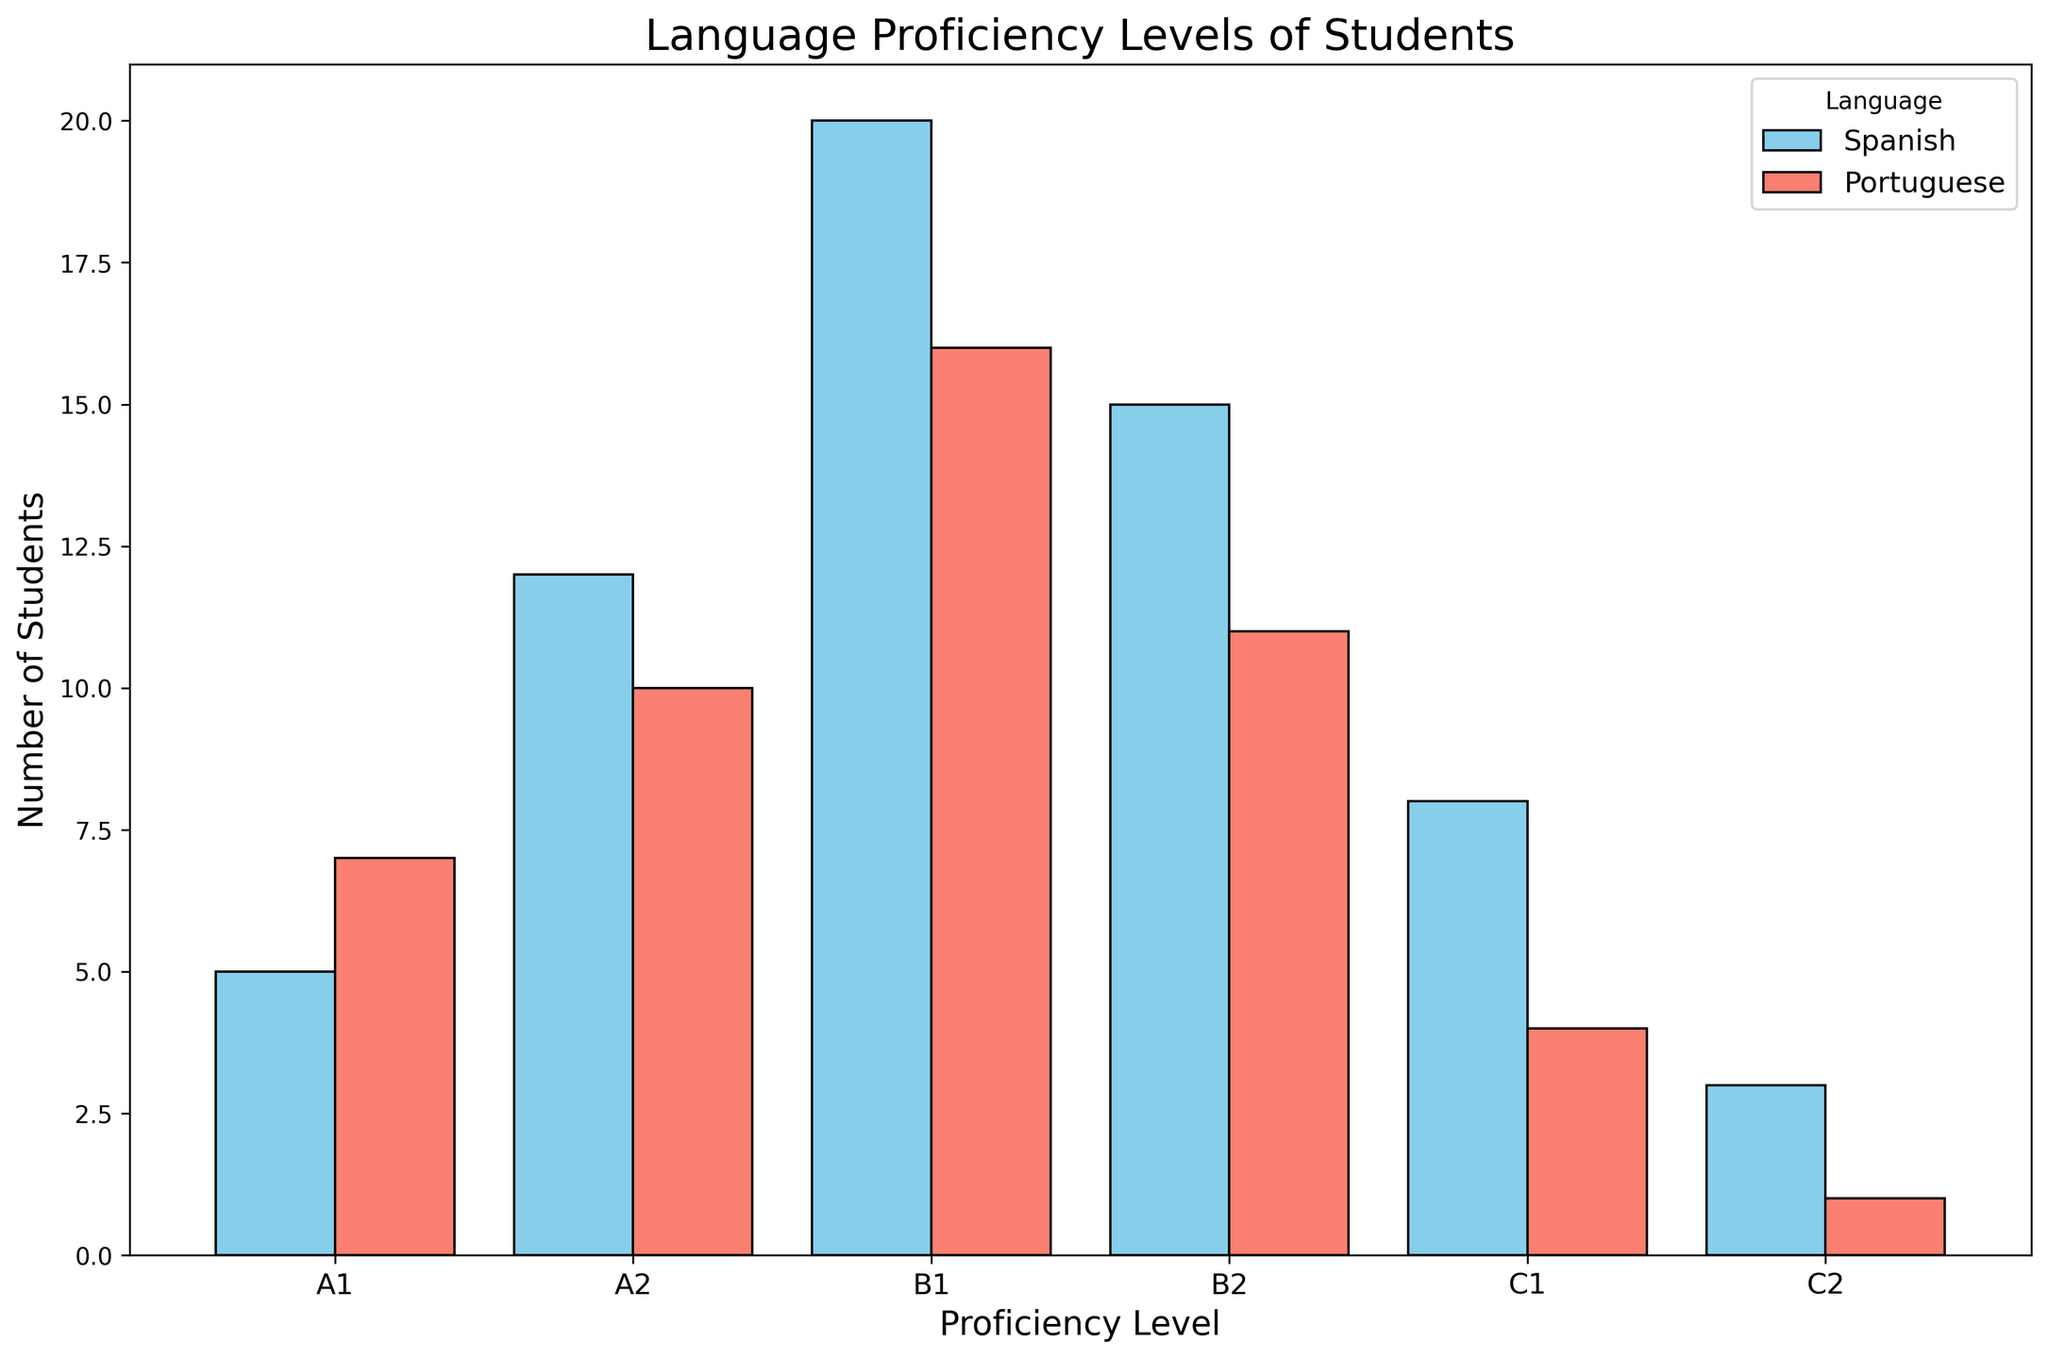What is the total number of students in the Spanish C1 and C2 proficiency levels? To find the total number of students in Spanish C1 and C2 levels, we sum the corresponding values: 8 (C1) + 3 (C2).
Answer: 11 Which language has more students in the B1 proficiency level? We compare the number of students in B1 proficiency level for Spanish and Portuguese. Spanish has 20 students, while Portuguese has 16 students.
Answer: Spanish What is the difference in the number of students between Spanish A2 and Portuguese A2 proficiency levels? The number of students in Spanish A2 is 12, and in Portuguese A2 it is 10. To find the difference, we calculate 12 - 10.
Answer: 2 Which proficiency level has the fewest students in Portuguese, and how many students are there? We look for the smallest bar in the Portuguese section, which corresponds to the C2 level. The number of students here is 1.
Answer: C2, 1 Are there more students in Portuguese B2 than in Spanish C1? If so, by how many? The number of students in Portuguese B2 is 11 and in Spanish C1 is 8. Since 11 > 8, we calculate the difference: 11 - 8.
Answer: Yes, by 3 What's the total number of students across all proficiency levels for both languages? We sum the numbers for all proficiency levels in both Spanish and Portuguese: (5+12+20+15+8+3) + (7+10+16+11+4+1). First, sum each language separately: Spanish = 63, Portuguese = 49. Then add both: 63 + 49.
Answer: 112 Which language has a wider distribution of students among proficiency levels, and how can you tell? Analysis of the bar lengths for each proficiency level shows that Spanish has a more even distribution (larger bars across more levels) compared to Portuguese, which has fewer students in higher levels (smaller bars).
Answer: Spanish What is the average number of students in the A1 level for both languages combined? Combine the number of students in A1 for both languages: 5 (Spanish) + 7 (Portuguese), then divide by 2 to get the average: (5+7)/2.
Answer: 6 How many more students are there in Spanish B1 compared to Portuguese B2? Compare the number of students in Spanish B1 (20) with Portuguese B2 (11) and calculate the difference: 20 - 11.
Answer: 9 In which proficiency level does Spanish have the greatest number of students, and how many students are there? Find the highest bar in the Spanish section, which corresponds to B1. The number of students is 20.
Answer: B1, 20 